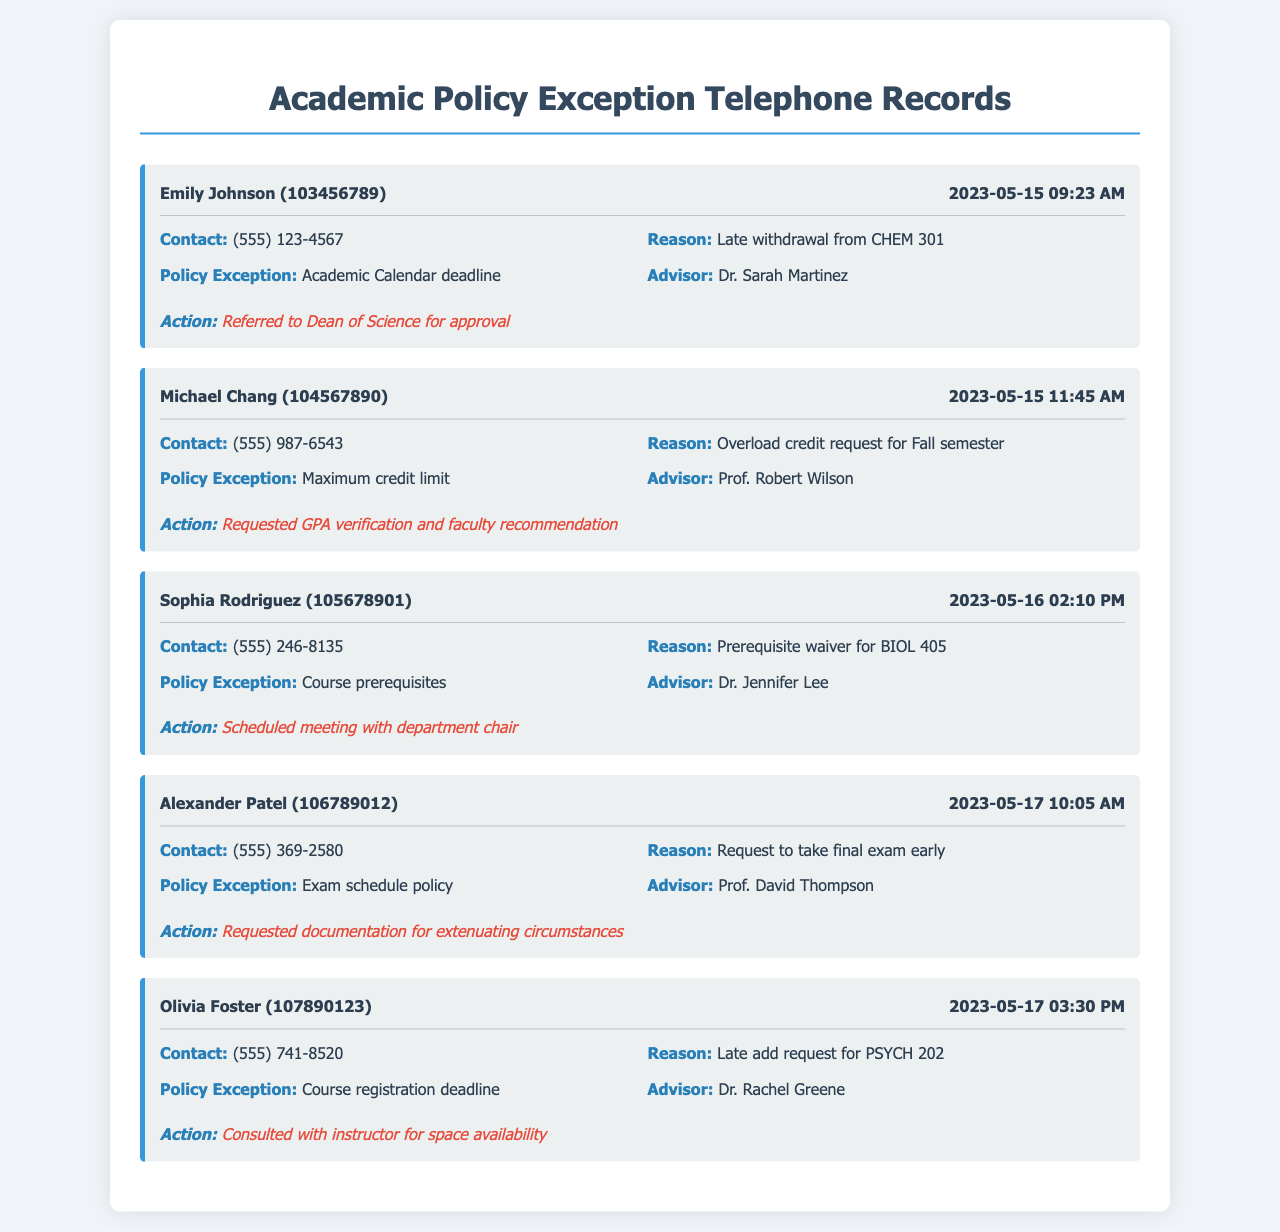What is the name of the first student seeking an exception? The first student's name is listed at the beginning of the record.
Answer: Emily Johnson What was the reason for Michael Chang's call? The reason is clearly stated as part of the record's information.
Answer: Overload credit request for Fall semester What date did Sophia Rodriguez make her call? The date is provided alongside the student's name in the record header.
Answer: 2023-05-16 Who is the advisor for Alexander Patel? The advisor's name is specified in the record body under each student's details.
Answer: Prof. David Thompson What policy exception is Olivia Foster requesting? This information is listed explicitly alongside the reason for the call in the record.
Answer: Course registration deadline What action was taken for Emily Johnson's request? The action taken is summarized in the last part of each record.
Answer: Referred to Dean of Science for approval Which student's request involves a prerequisite waiver? The student's information will include specific details regarding requests, including prerequisites.
Answer: Sophia Rodriguez How many students requested exceptions on May 17, 2023? By reviewing the records for that date, we can determine the number of requests.
Answer: 2 What is the contact number for Michael Chang? The contact number is listed under the record body alongside each student's details.
Answer: (555) 987-6543 